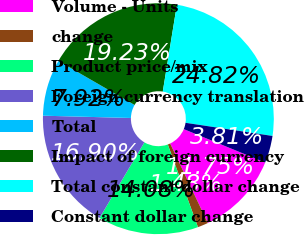Convert chart to OTSL. <chart><loc_0><loc_0><loc_500><loc_500><pie_chart><fcel>Volume - Units<fcel>change<fcel>Product price/mix<fcel>Foreign currency translation<fcel>Total<fcel>Impact of foreign currency<fcel>Total constant dollar change<fcel>Constant dollar change<nl><fcel>11.75%<fcel>1.48%<fcel>14.08%<fcel>16.9%<fcel>7.92%<fcel>19.23%<fcel>24.82%<fcel>3.81%<nl></chart> 